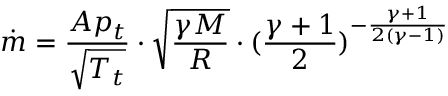Convert formula to latex. <formula><loc_0><loc_0><loc_500><loc_500>{ \dot { m } } = { \frac { A p _ { t } } { \sqrt { T _ { t } } } } \cdot { \sqrt { \frac { \gamma M } { R } } } \cdot ( { \frac { \gamma + 1 } { 2 } } ) ^ { - { \frac { \gamma + 1 } { 2 ( \gamma - 1 ) } } }</formula> 